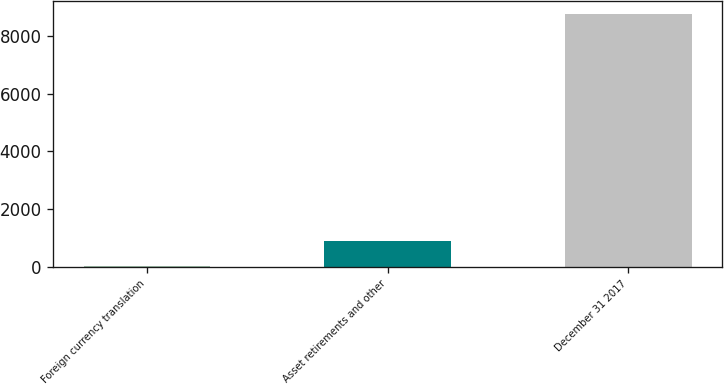Convert chart. <chart><loc_0><loc_0><loc_500><loc_500><bar_chart><fcel>Foreign currency translation<fcel>Asset retirements and other<fcel>December 31 2017<nl><fcel>25<fcel>901.3<fcel>8788<nl></chart> 